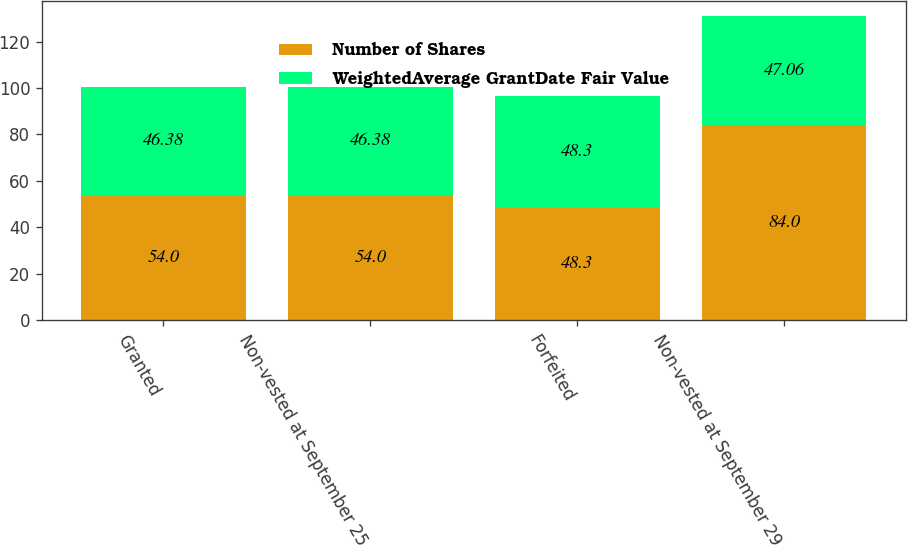Convert chart. <chart><loc_0><loc_0><loc_500><loc_500><stacked_bar_chart><ecel><fcel>Granted<fcel>Non-vested at September 25<fcel>Forfeited<fcel>Non-vested at September 29<nl><fcel>Number of Shares<fcel>54<fcel>54<fcel>48.3<fcel>84<nl><fcel>WeightedAverage GrantDate Fair Value<fcel>46.38<fcel>46.38<fcel>48.3<fcel>47.06<nl></chart> 